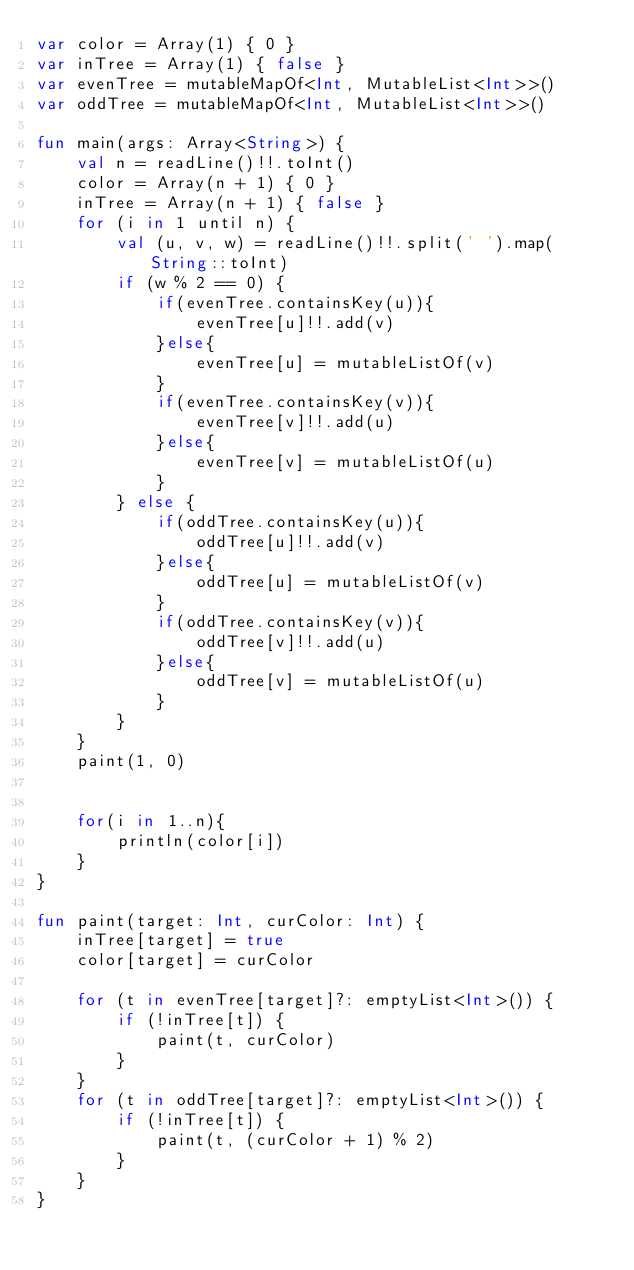<code> <loc_0><loc_0><loc_500><loc_500><_Kotlin_>var color = Array(1) { 0 }
var inTree = Array(1) { false }
var evenTree = mutableMapOf<Int, MutableList<Int>>()
var oddTree = mutableMapOf<Int, MutableList<Int>>()

fun main(args: Array<String>) {
    val n = readLine()!!.toInt()
    color = Array(n + 1) { 0 }
    inTree = Array(n + 1) { false }
    for (i in 1 until n) {
        val (u, v, w) = readLine()!!.split(' ').map(String::toInt)
        if (w % 2 == 0) {
            if(evenTree.containsKey(u)){
                evenTree[u]!!.add(v)
            }else{
                evenTree[u] = mutableListOf(v)
            }
            if(evenTree.containsKey(v)){
                evenTree[v]!!.add(u)
            }else{
                evenTree[v] = mutableListOf(u)
            }
        } else {
            if(oddTree.containsKey(u)){
                oddTree[u]!!.add(v)
            }else{
                oddTree[u] = mutableListOf(v)
            }
            if(oddTree.containsKey(v)){
                oddTree[v]!!.add(u)
            }else{
                oddTree[v] = mutableListOf(u)
            }
        }
    }
    paint(1, 0)


    for(i in 1..n){
        println(color[i])
    }
}

fun paint(target: Int, curColor: Int) {
    inTree[target] = true
    color[target] = curColor

    for (t in evenTree[target]?: emptyList<Int>()) {
        if (!inTree[t]) {
            paint(t, curColor)
        }
    }
    for (t in oddTree[target]?: emptyList<Int>()) {
        if (!inTree[t]) {
            paint(t, (curColor + 1) % 2)
        }
    }
}</code> 